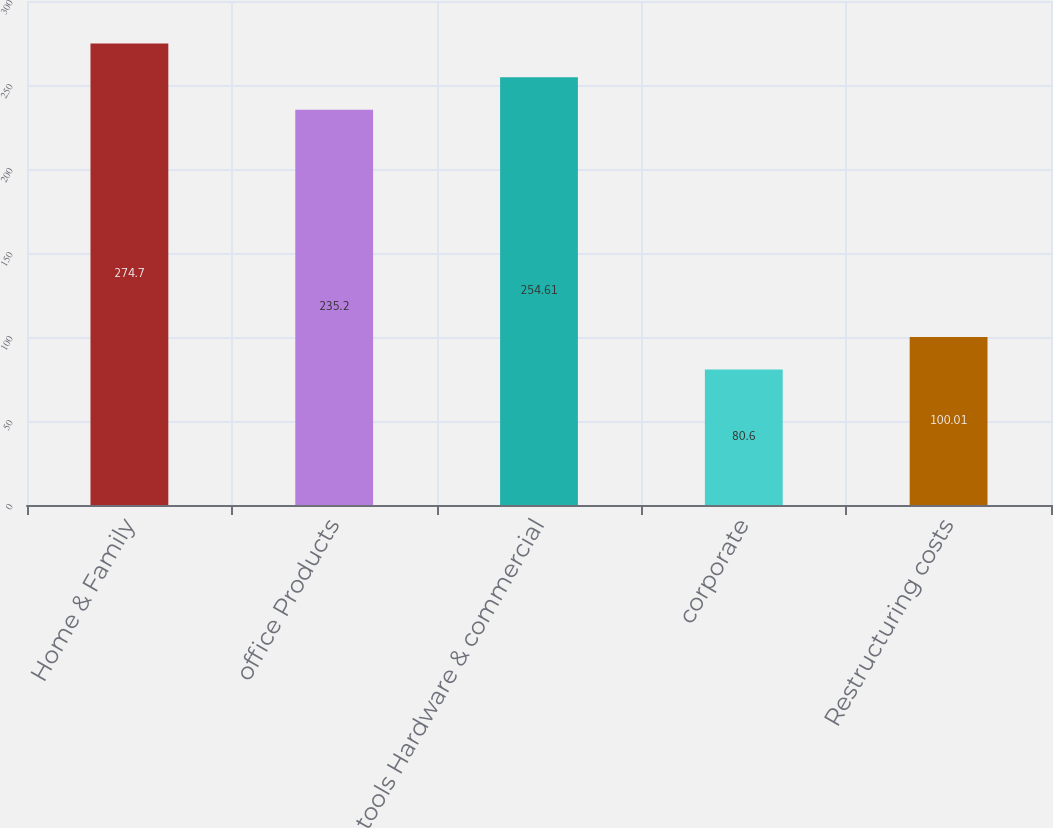Convert chart to OTSL. <chart><loc_0><loc_0><loc_500><loc_500><bar_chart><fcel>Home & Family<fcel>office Products<fcel>tools Hardware & commercial<fcel>corporate<fcel>Restructuring costs<nl><fcel>274.7<fcel>235.2<fcel>254.61<fcel>80.6<fcel>100.01<nl></chart> 